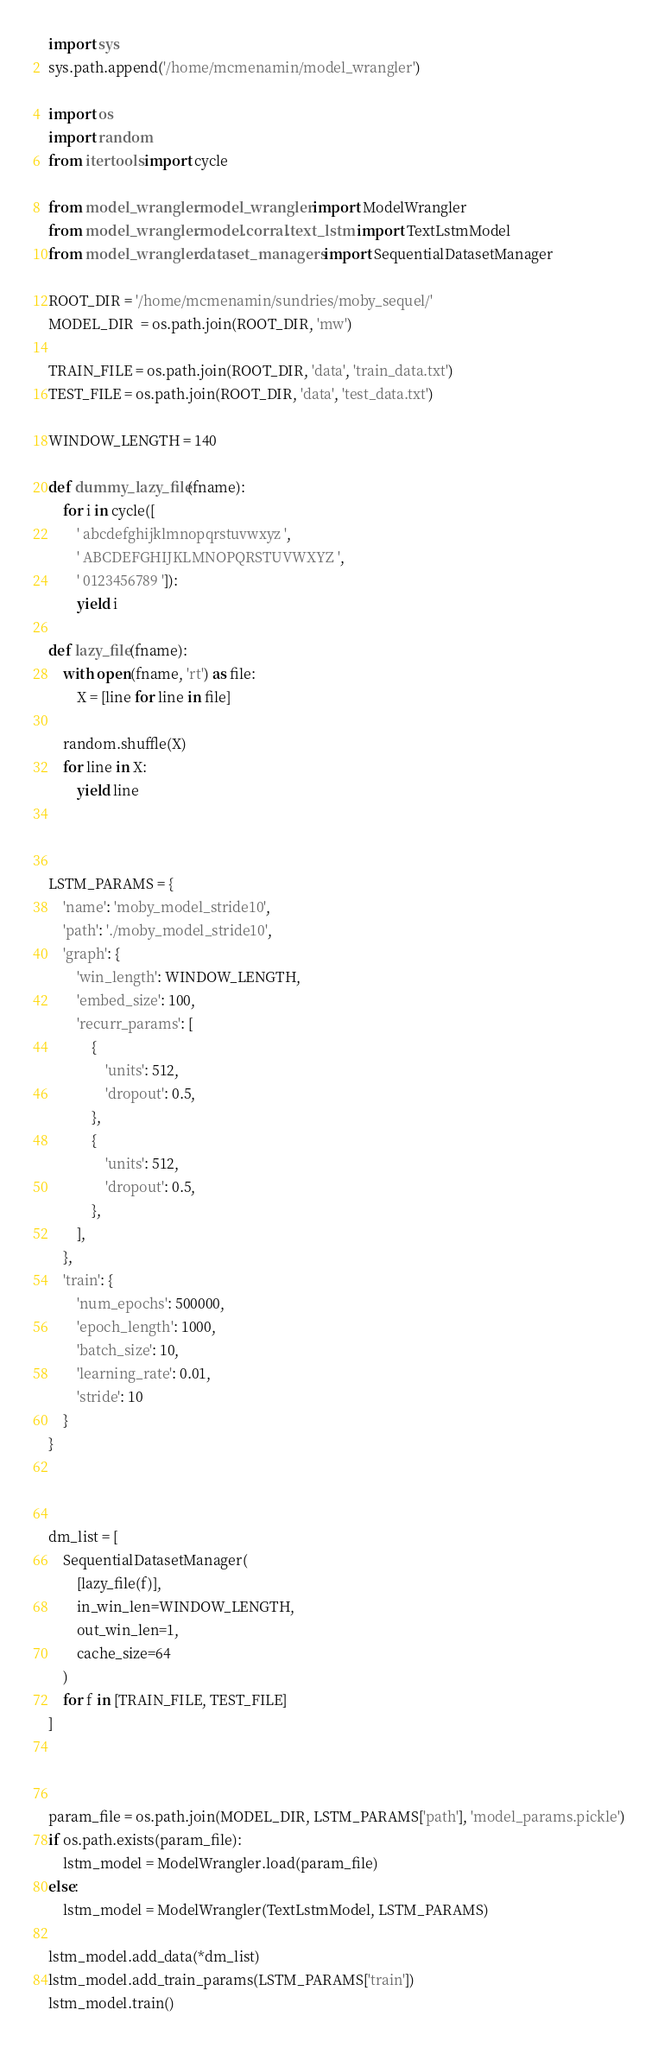Convert code to text. <code><loc_0><loc_0><loc_500><loc_500><_Python_>import sys
sys.path.append('/home/mcmenamin/model_wrangler')

import os
import random
from itertools import cycle

from model_wrangler.model_wrangler import ModelWrangler
from model_wrangler.model.corral.text_lstm import TextLstmModel
from model_wrangler.dataset_managers import SequentialDatasetManager

ROOT_DIR = '/home/mcmenamin/sundries/moby_sequel/'
MODEL_DIR  = os.path.join(ROOT_DIR, 'mw')

TRAIN_FILE = os.path.join(ROOT_DIR, 'data', 'train_data.txt')
TEST_FILE = os.path.join(ROOT_DIR, 'data', 'test_data.txt')

WINDOW_LENGTH = 140

def dummy_lazy_file(fname):
    for i in cycle([
        ' abcdefghijklmnopqrstuvwxyz ',
        ' ABCDEFGHIJKLMNOPQRSTUVWXYZ ',
        ' 0123456789 ']):
        yield i

def lazy_file(fname):
    with open(fname, 'rt') as file:
        X = [line for line in file]

    random.shuffle(X)
    for line in X:
    	yield line



LSTM_PARAMS = {
    'name': 'moby_model_stride10',
    'path': './moby_model_stride10',
    'graph': {
        'win_length': WINDOW_LENGTH,
        'embed_size': 100,
        'recurr_params': [
            {
                'units': 512,
                'dropout': 0.5,
            },
            {
                'units': 512,
                'dropout': 0.5,
            },
        ],
    },
    'train': {
        'num_epochs': 500000,
        'epoch_length': 1000,
        'batch_size': 10,
        'learning_rate': 0.01,
        'stride': 10
    }
}



dm_list = [
    SequentialDatasetManager(
        [lazy_file(f)],
        in_win_len=WINDOW_LENGTH,
        out_win_len=1,
        cache_size=64
    )
    for f in [TRAIN_FILE, TEST_FILE]
]



param_file = os.path.join(MODEL_DIR, LSTM_PARAMS['path'], 'model_params.pickle')
if os.path.exists(param_file):
    lstm_model = ModelWrangler.load(param_file)
else:
    lstm_model = ModelWrangler(TextLstmModel, LSTM_PARAMS)

lstm_model.add_data(*dm_list)
lstm_model.add_train_params(LSTM_PARAMS['train'])
lstm_model.train()
</code> 